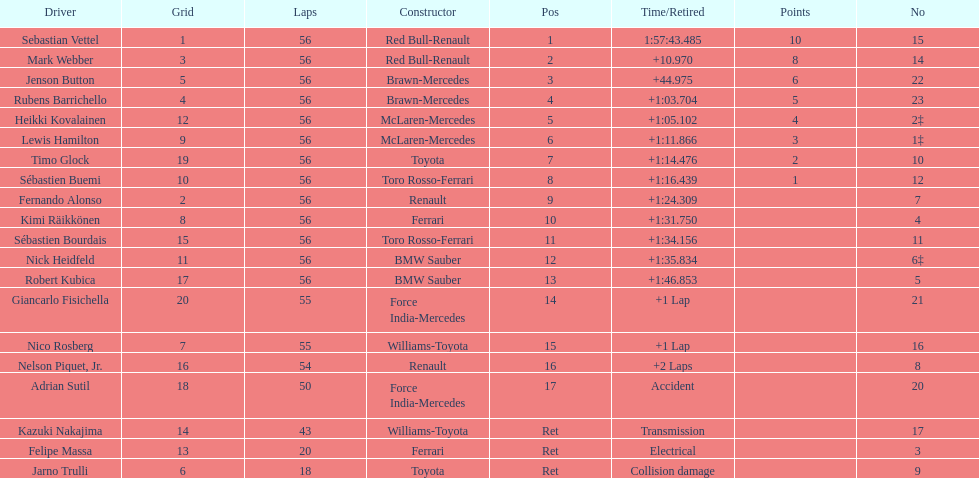Who are all of the drivers? Sebastian Vettel, Mark Webber, Jenson Button, Rubens Barrichello, Heikki Kovalainen, Lewis Hamilton, Timo Glock, Sébastien Buemi, Fernando Alonso, Kimi Räikkönen, Sébastien Bourdais, Nick Heidfeld, Robert Kubica, Giancarlo Fisichella, Nico Rosberg, Nelson Piquet, Jr., Adrian Sutil, Kazuki Nakajima, Felipe Massa, Jarno Trulli. Who were their constructors? Red Bull-Renault, Red Bull-Renault, Brawn-Mercedes, Brawn-Mercedes, McLaren-Mercedes, McLaren-Mercedes, Toyota, Toro Rosso-Ferrari, Renault, Ferrari, Toro Rosso-Ferrari, BMW Sauber, BMW Sauber, Force India-Mercedes, Williams-Toyota, Renault, Force India-Mercedes, Williams-Toyota, Ferrari, Toyota. Who was the first listed driver to not drive a ferrari?? Sebastian Vettel. 